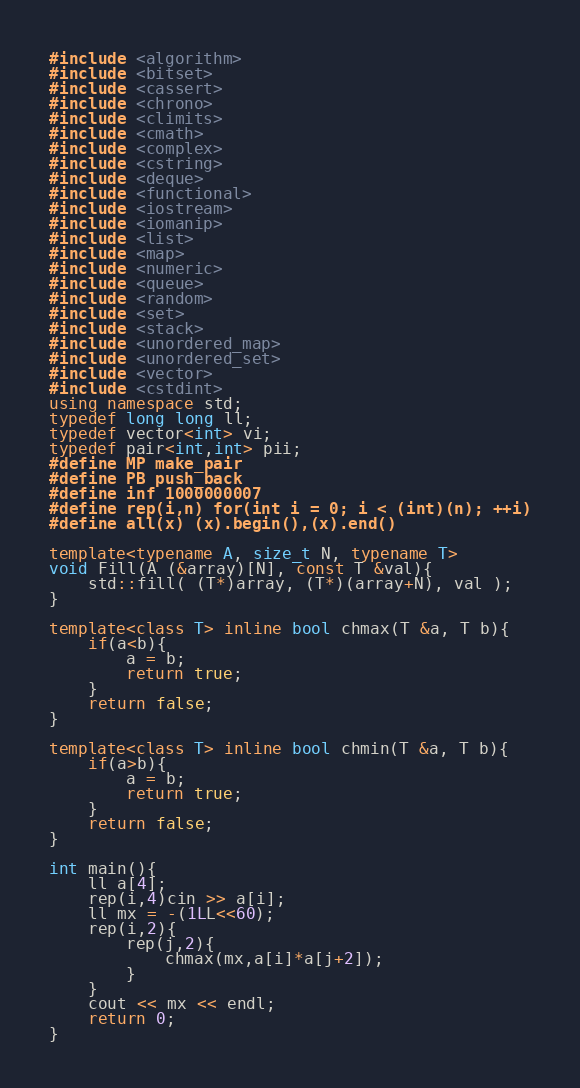<code> <loc_0><loc_0><loc_500><loc_500><_C++_>#include <algorithm>
#include <bitset>
#include <cassert>
#include <chrono>
#include <climits>
#include <cmath>
#include <complex>
#include <cstring>
#include <deque>
#include <functional>
#include <iostream>
#include <iomanip>
#include <list>
#include <map>
#include <numeric>
#include <queue>
#include <random>
#include <set>
#include <stack>
#include <unordered_map>
#include <unordered_set>
#include <vector>
#include <cstdint>
using namespace std;
typedef long long ll;
typedef vector<int> vi;
typedef pair<int,int> pii;
#define MP make_pair
#define PB push_back
#define inf 1000000007
#define rep(i,n) for(int i = 0; i < (int)(n); ++i)
#define all(x) (x).begin(),(x).end()

template<typename A, size_t N, typename T>
void Fill(A (&array)[N], const T &val){
    std::fill( (T*)array, (T*)(array+N), val );
}
 
template<class T> inline bool chmax(T &a, T b){
    if(a<b){
        a = b;
        return true;
    }
    return false;
}

template<class T> inline bool chmin(T &a, T b){
    if(a>b){
        a = b;
        return true;
    }
    return false;
}

int main(){
    ll a[4];
    rep(i,4)cin >> a[i];
    ll mx = -(1LL<<60);
    rep(i,2){
        rep(j,2){
            chmax(mx,a[i]*a[j+2]);
        }
    }    
    cout << mx << endl;
    return 0;
}</code> 